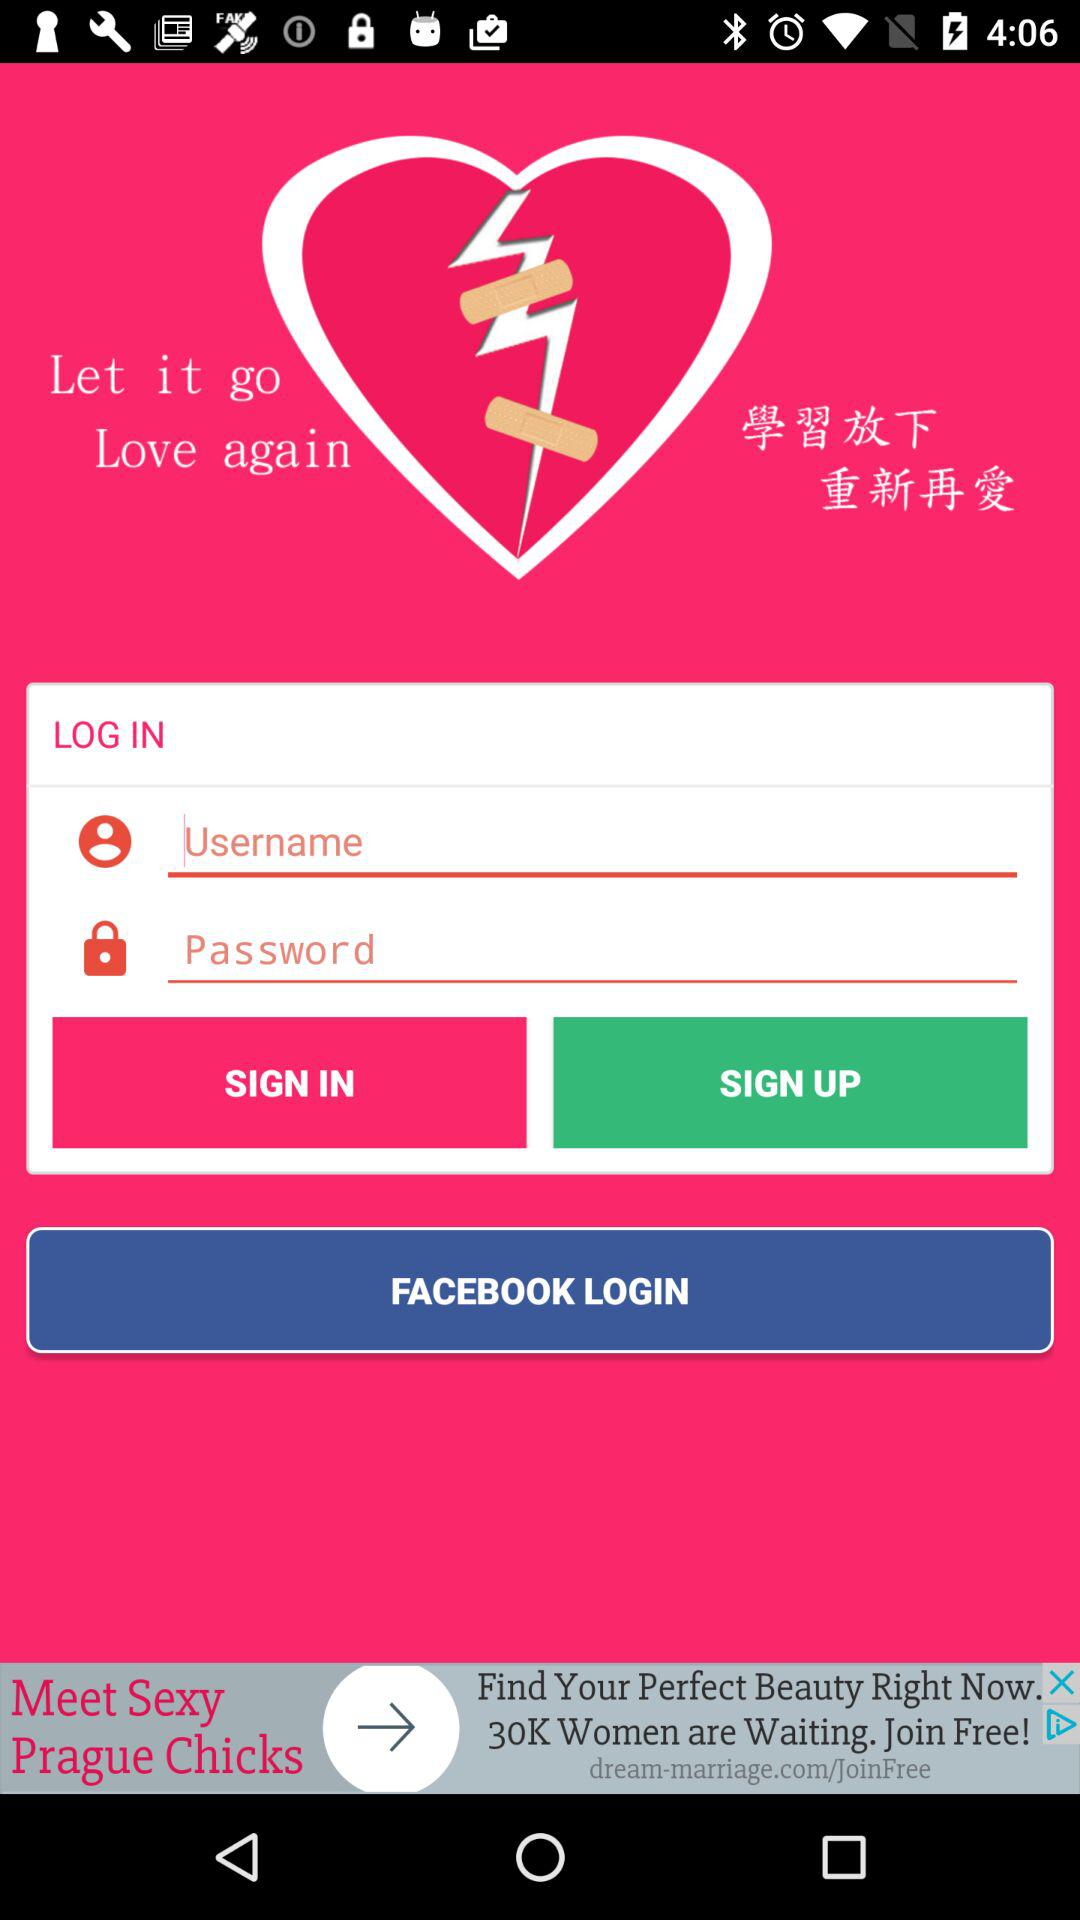Through what account can logging in be done? Logging in can be done through "FACEBOOK". 